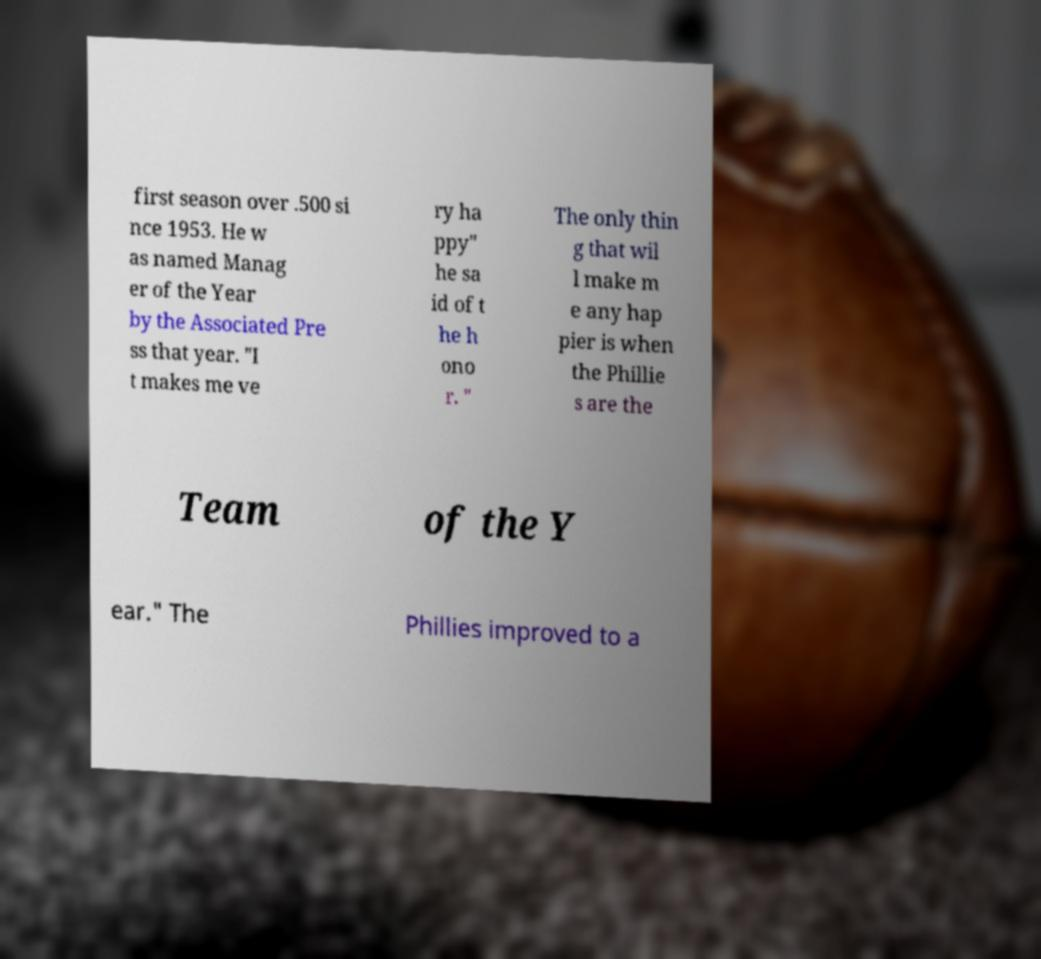Could you assist in decoding the text presented in this image and type it out clearly? first season over .500 si nce 1953. He w as named Manag er of the Year by the Associated Pre ss that year. "I t makes me ve ry ha ppy" he sa id of t he h ono r. " The only thin g that wil l make m e any hap pier is when the Phillie s are the Team of the Y ear." The Phillies improved to a 